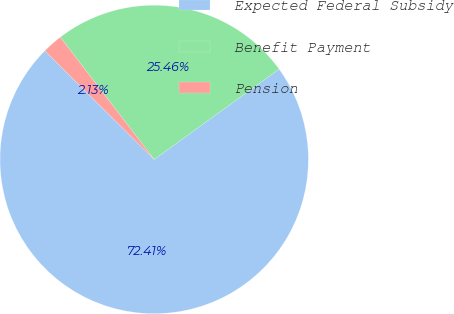Convert chart to OTSL. <chart><loc_0><loc_0><loc_500><loc_500><pie_chart><fcel>Expected Federal Subsidy<fcel>Benefit Payment<fcel>Pension<nl><fcel>72.42%<fcel>25.46%<fcel>2.13%<nl></chart> 